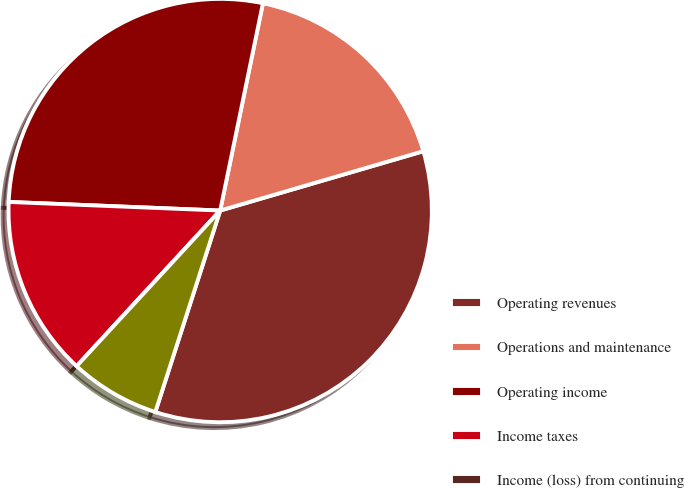Convert chart to OTSL. <chart><loc_0><loc_0><loc_500><loc_500><pie_chart><fcel>Operating revenues<fcel>Operations and maintenance<fcel>Operating income<fcel>Income taxes<fcel>Income (loss) from continuing<fcel>Net income (loss) attributable<nl><fcel>34.48%<fcel>17.24%<fcel>27.59%<fcel>13.79%<fcel>0.0%<fcel>6.9%<nl></chart> 